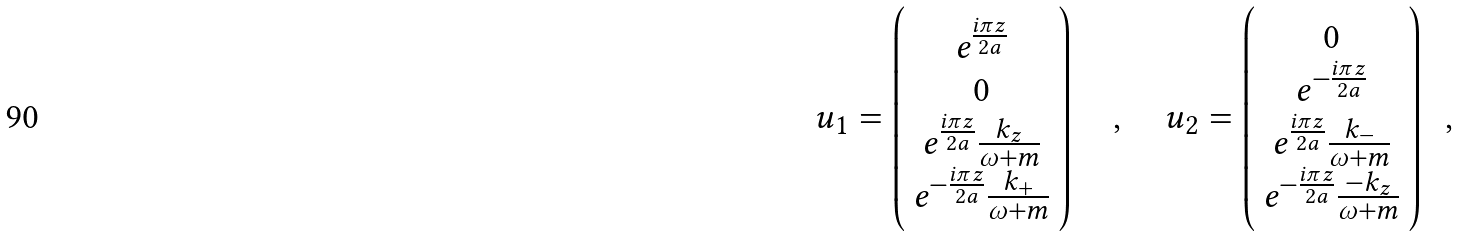<formula> <loc_0><loc_0><loc_500><loc_500>u _ { 1 } = \left ( \begin{array} { c } e ^ { \frac { i \pi { z } } { 2 a } } \\ 0 \\ e ^ { \frac { i \pi { z } } { 2 a } } \frac { k _ { z } } { \omega + m } \\ e ^ { - \frac { i \pi { z } } { 2 a } } \frac { k _ { + } } { \omega + m } \end{array} \right ) \quad , \quad u _ { 2 } = \left ( \begin{array} { c } 0 \\ e ^ { - \frac { i \pi { z } } { 2 a } } \\ e ^ { \frac { i \pi { z } } { 2 a } } \frac { k _ { - } } { \omega + m } \\ e ^ { - \frac { i \pi { z } } { 2 a } } \frac { - k _ { z } } { \omega + m } \end{array} \right ) \ \ ,</formula> 